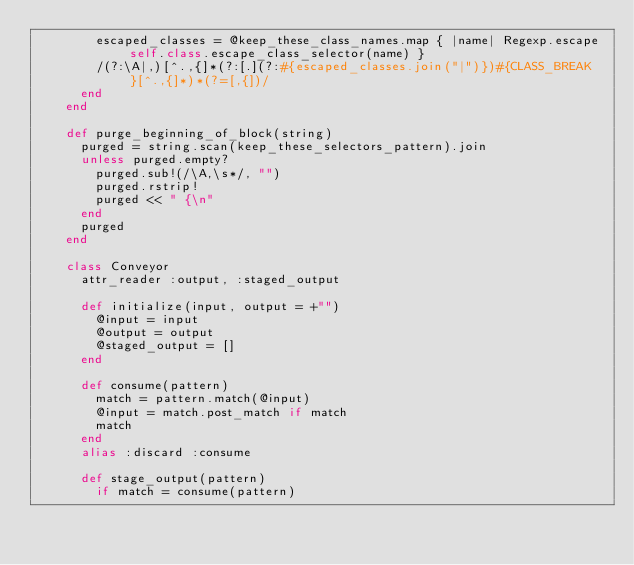<code> <loc_0><loc_0><loc_500><loc_500><_Ruby_>        escaped_classes = @keep_these_class_names.map { |name| Regexp.escape self.class.escape_class_selector(name) }
        /(?:\A|,)[^.,{]*(?:[.](?:#{escaped_classes.join("|")})#{CLASS_BREAK}[^.,{]*)*(?=[,{])/
      end
    end

    def purge_beginning_of_block(string)
      purged = string.scan(keep_these_selectors_pattern).join
      unless purged.empty?
        purged.sub!(/\A,\s*/, "")
        purged.rstrip!
        purged << " {\n"
      end
      purged
    end

    class Conveyor
      attr_reader :output, :staged_output

      def initialize(input, output = +"")
        @input = input
        @output = output
        @staged_output = []
      end

      def consume(pattern)
        match = pattern.match(@input)
        @input = match.post_match if match
        match
      end
      alias :discard :consume

      def stage_output(pattern)
        if match = consume(pattern)</code> 